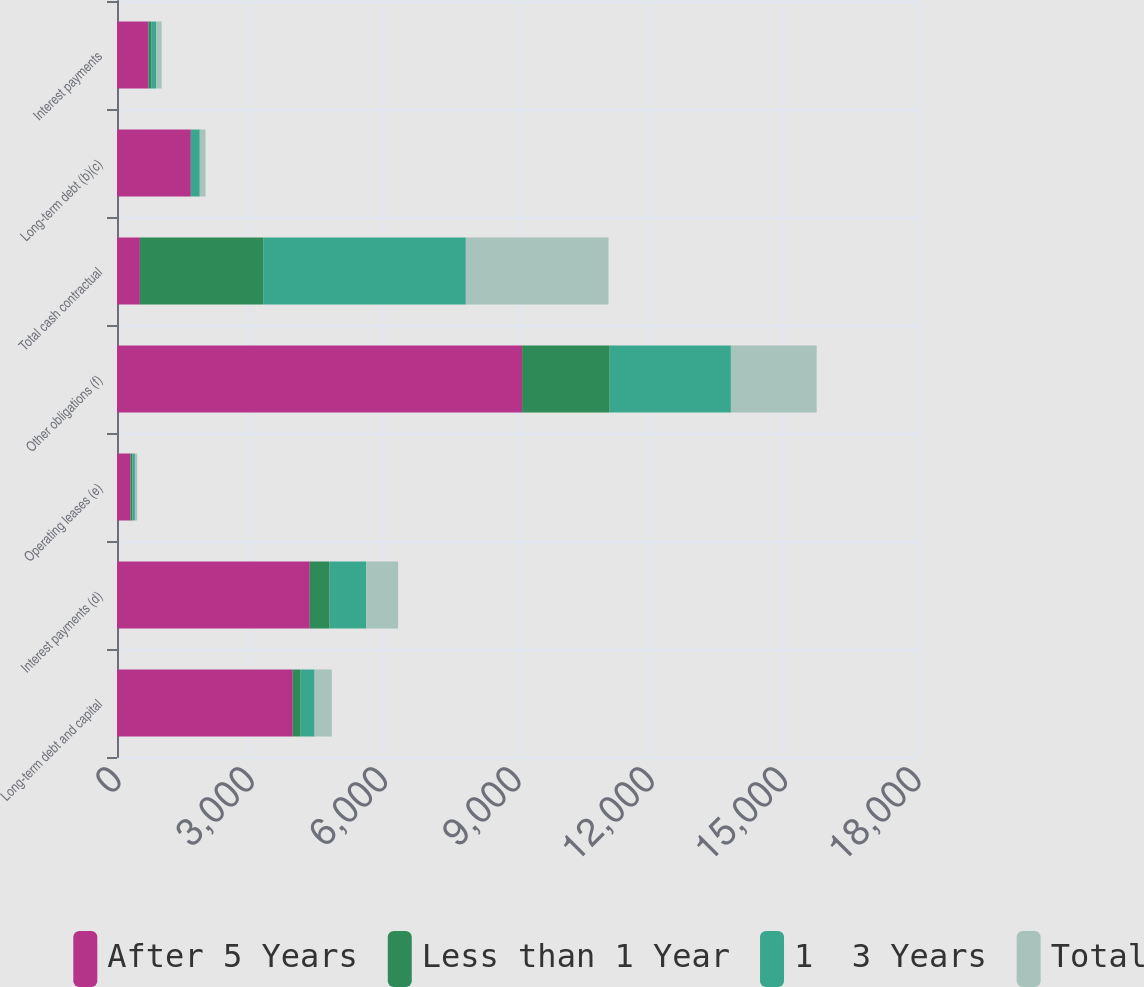Convert chart. <chart><loc_0><loc_0><loc_500><loc_500><stacked_bar_chart><ecel><fcel>Long-term debt and capital<fcel>Interest payments (d)<fcel>Operating leases (e)<fcel>Other obligations (f)<fcel>Total cash contractual<fcel>Long-term debt (b)(c)<fcel>Interest payments<nl><fcel>After 5 Years<fcel>3955<fcel>4338<fcel>307<fcel>9114<fcel>515<fcel>1661<fcel>710<nl><fcel>Less than 1 Year<fcel>178<fcel>446<fcel>38<fcel>1972<fcel>2783<fcel>1<fcel>59<nl><fcel>1  3 Years<fcel>314<fcel>826<fcel>58<fcel>2727<fcel>4551<fcel>201<fcel>118<nl><fcel>Total<fcel>386<fcel>715<fcel>51<fcel>1929<fcel>3210<fcel>129<fcel>118<nl></chart> 